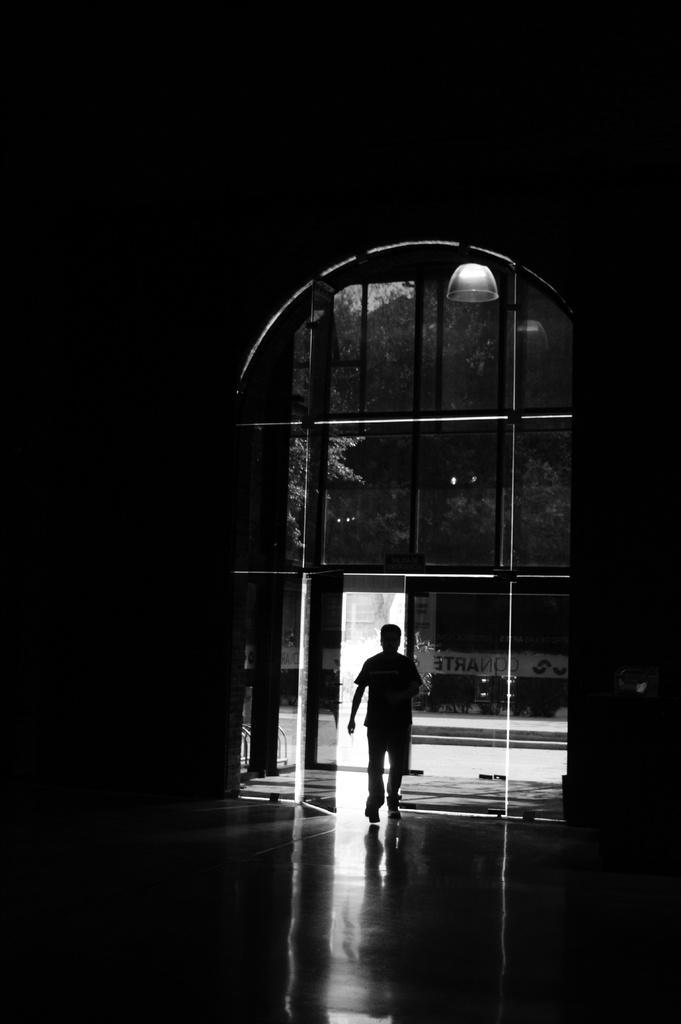Describe this image in one or two sentences. This is a black and white image. We can see a person and the ground. We can see some glass and the door. There are a few trees. We can also see a light and some text. 